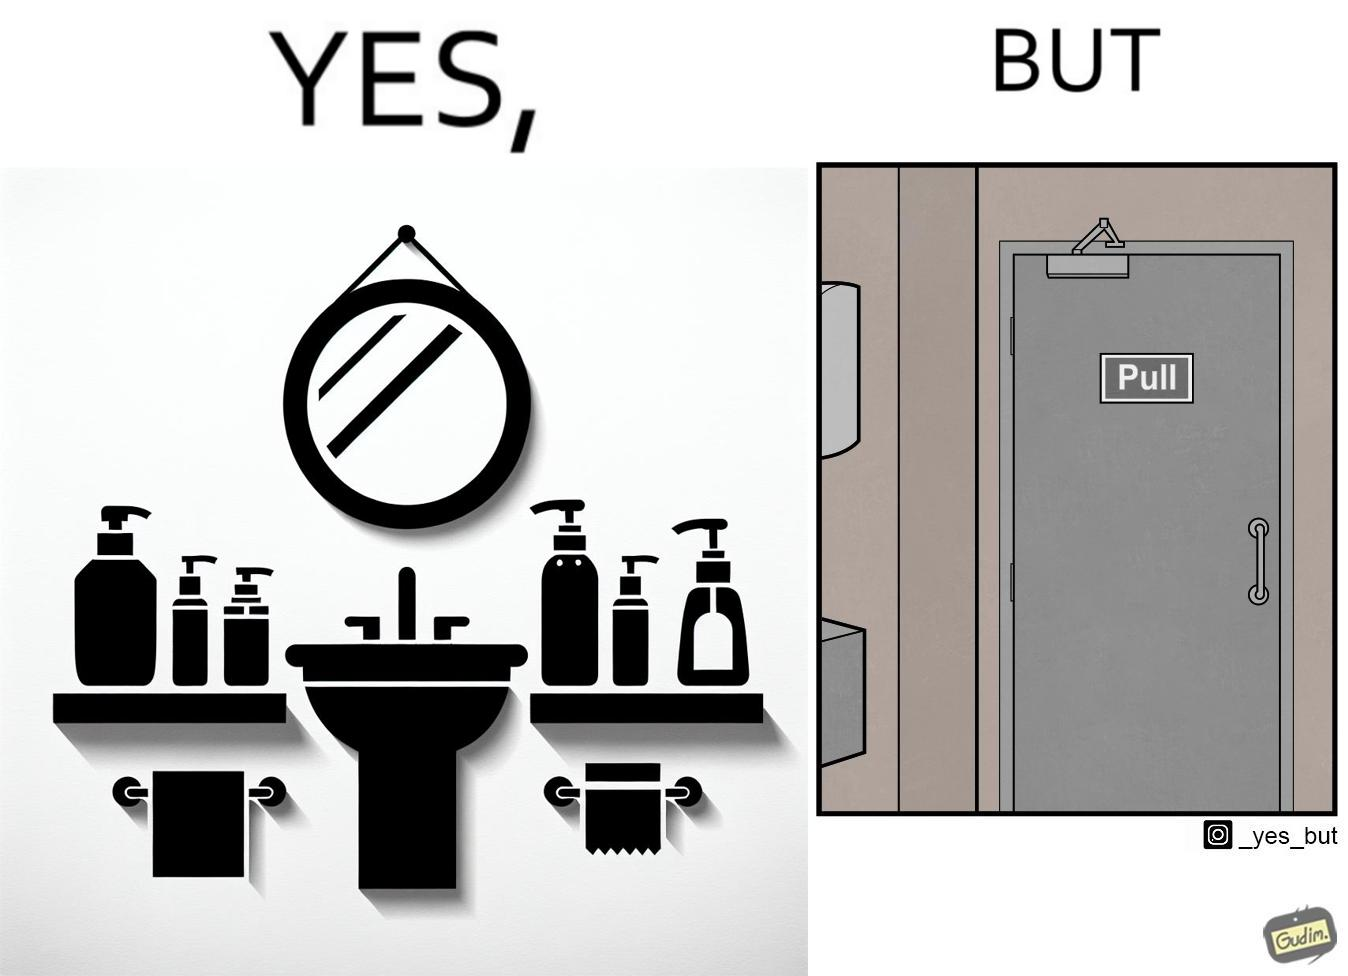Describe the satirical element in this image. The image is ironic, because in the first image in the bathroom there are so many things to clean hands around the basin but in the same bathroom people have to open the doors by hand which can easily spread the germs or bacteria even after times of hand cleaning as there is no way to open it without hands 